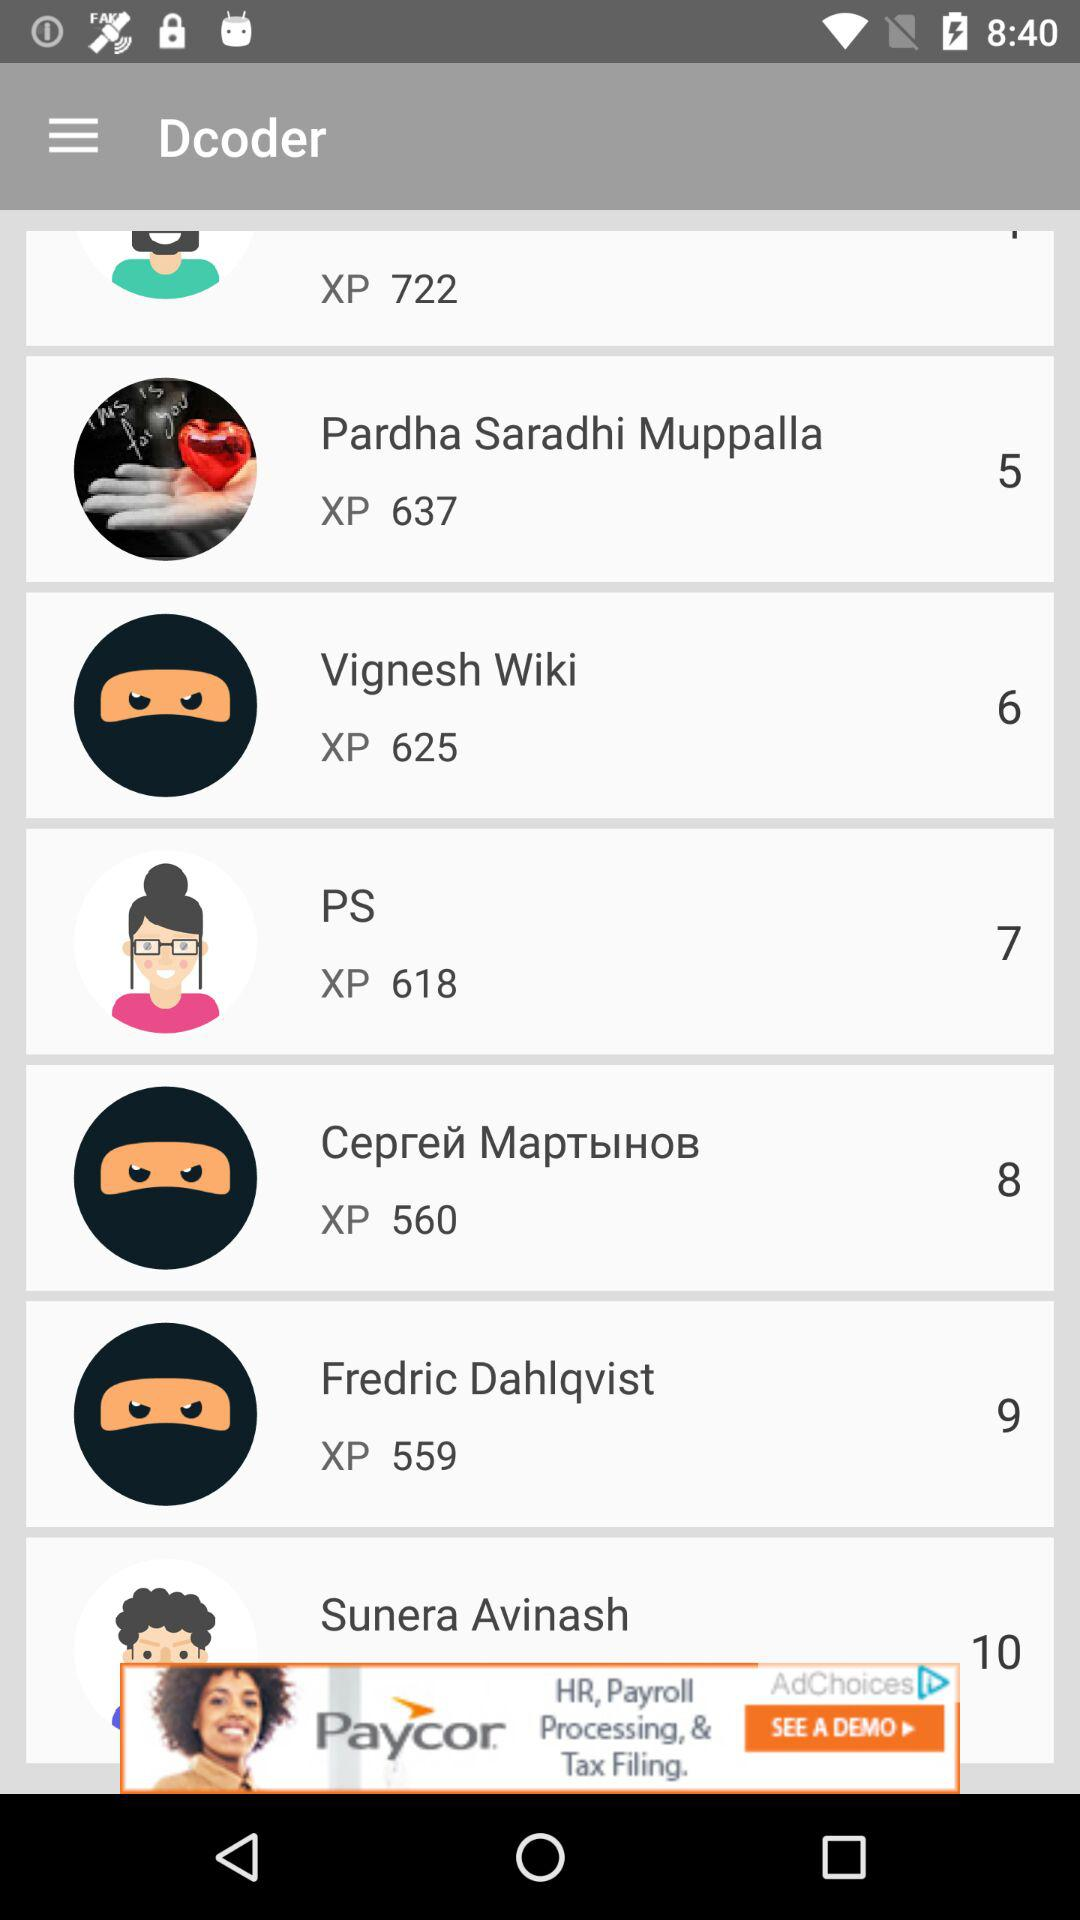Whose name is on the "XP 625"? The name is Vignesh Wiki. 